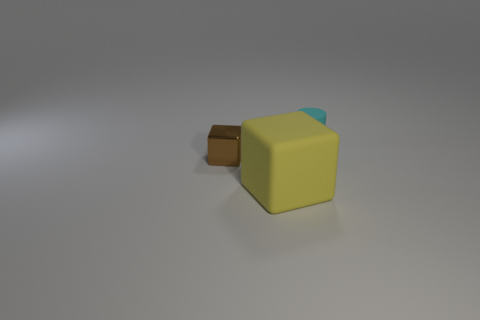Does this object look like it belongs to a particular set or collection? Given the simplistic design and the block-like structure of the object, it could possibly be part of a children's toy set, designed for building or educational purposes. 